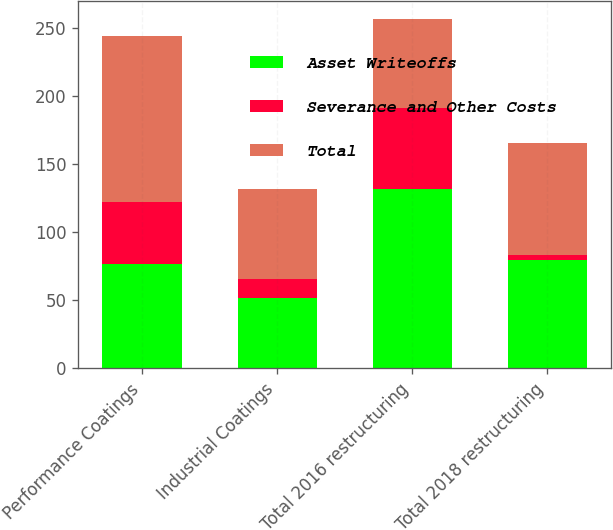Convert chart. <chart><loc_0><loc_0><loc_500><loc_500><stacked_bar_chart><ecel><fcel>Performance Coatings<fcel>Industrial Coatings<fcel>Total 2016 restructuring<fcel>Total 2018 restructuring<nl><fcel>Asset Writeoffs<fcel>77<fcel>52<fcel>132<fcel>80<nl><fcel>Severance and Other Costs<fcel>45<fcel>14<fcel>59<fcel>3<nl><fcel>Total<fcel>122<fcel>66<fcel>66<fcel>83<nl></chart> 